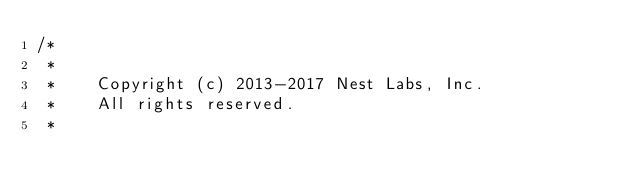Convert code to text. <code><loc_0><loc_0><loc_500><loc_500><_C++_>/*
 *
 *    Copyright (c) 2013-2017 Nest Labs, Inc.
 *    All rights reserved.
 *</code> 